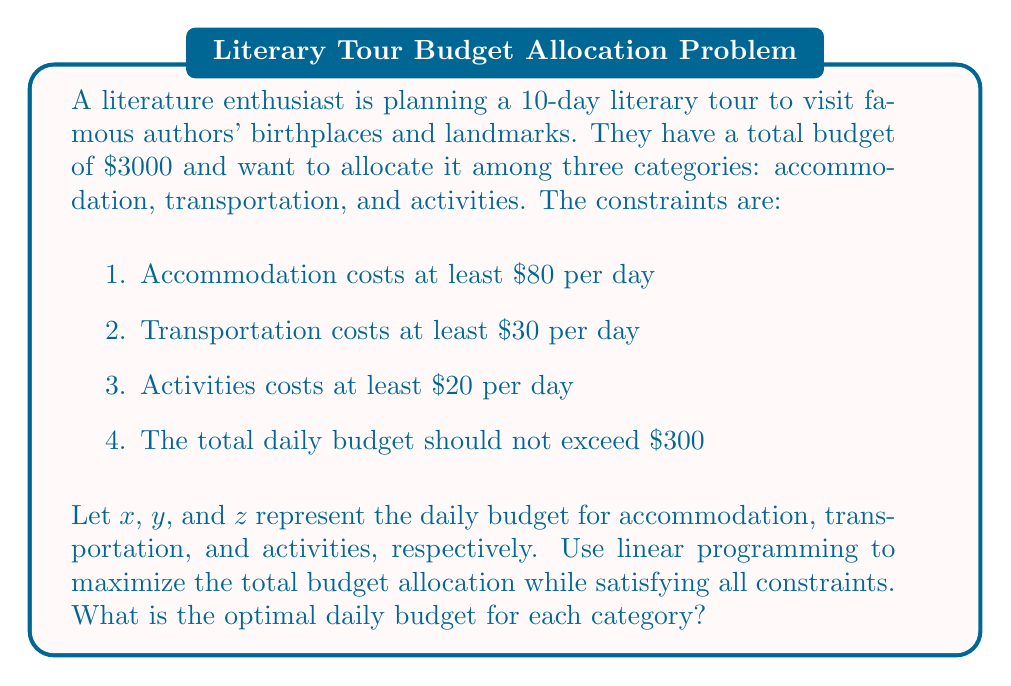Give your solution to this math problem. To solve this linear programming problem, we need to set up the objective function and constraints, then solve using the simplex method or graphical method. Let's approach this step-by-step:

1. Objective function:
   Maximize $f(x, y, z) = x + y + z$

2. Constraints:
   $$\begin{align}
   x &\geq 80 \\
   y &\geq 30 \\
   z &\geq 20 \\
   x + y + z &\leq 300
   \end{align}$$

3. Non-negativity constraints:
   $x, y, z \geq 0$

4. To solve this, we can use the simplex method or graphical method. Given the simplicity of the problem, let's use the graphical method.

5. First, we plot the feasible region based on the constraints:

   [asy]
   import geometry;
   
   size(200);
   
   real xmax = 300;
   real ymax = 300;
   
   draw((0,0)--(xmax,0)--(xmax,ymax)--(0,ymax)--cycle);
   draw((80,0)--(80,ymax),dashed);
   draw((0,30)--(xmax,30),dashed);
   draw((0,0)--(xmax,ymax-xmax),dashed);
   
   label("x=80", (80,ymax/2), W);
   label("y=30", (xmax/2,30), N);
   label("x+y+z=300", (xmax/2,ymax/2-xmax/4), NW);
   label("Feasible Region", (150,100));
   
   fill((80,30)--(80,270)--(190,160)--(190,30)--cycle, gray(0.8));
   [/asy]

6. The optimal solution will be at one of the vertices of the feasible region. The vertices are:
   - (80, 30, 20)
   - (80, 30, 190)
   - (80, 200, 20)
   - (250, 30, 20)

7. Evaluating the objective function at each vertex:
   - f(80, 30, 20) = 130
   - f(80, 30, 190) = 300
   - f(80, 200, 20) = 300
   - f(250, 30, 20) = 300

8. The maximum value of the objective function is 300, which occurs at three vertices. Any point on the line segment connecting these vertices will also yield the maximum value.

9. To choose a specific solution, we can consider the preferences of the literature enthusiast. Since they are visiting landmarks and birthplaces, we might prioritize transportation and activities over accommodation. This leads us to choose the vertex (80, 200, 20) as our optimal solution.
Answer: The optimal daily budget allocation is:
Accommodation: $80
Transportation: $200
Activities: $20
Total daily budget: $300 